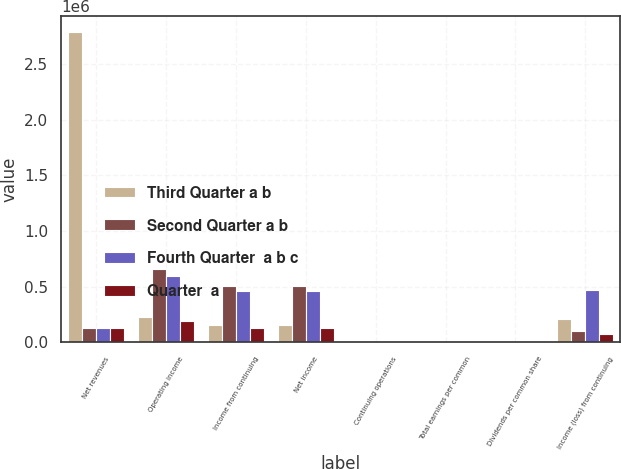<chart> <loc_0><loc_0><loc_500><loc_500><stacked_bar_chart><ecel><fcel>Net revenues<fcel>Operating income<fcel>Income from continuing<fcel>Net income<fcel>Continuing operations<fcel>Total earnings per common<fcel>Dividends per common share<fcel>Income (loss) from continuing<nl><fcel>Third Quarter a b<fcel>2.78815e+06<fcel>230882<fcel>159953<fcel>160358<fcel>0.4<fcel>0.4<fcel>0.46<fcel>213276<nl><fcel>Second Quarter a b<fcel>128804<fcel>658669<fcel>507121<fcel>507121<fcel>1.26<fcel>1.26<fcel>0.46<fcel>107092<nl><fcel>Fourth Quarter  a b c<fcel>128804<fcel>591905<fcel>463126<fcel>463509<fcel>1.16<fcel>1.16<fcel>0.51<fcel>473820<nl><fcel>Quarter  a<fcel>128804<fcel>194384<fcel>128804<fcel>128804<fcel>0.32<fcel>0.32<fcel>0.51<fcel>72979<nl></chart> 